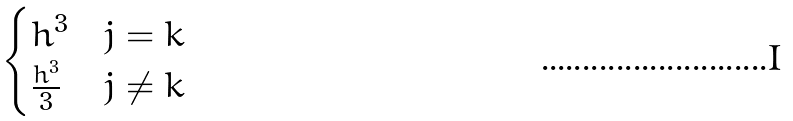Convert formula to latex. <formula><loc_0><loc_0><loc_500><loc_500>\begin{cases} h ^ { 3 } & j = k \\ \frac { h ^ { 3 } } 3 & j \neq k \end{cases}</formula> 